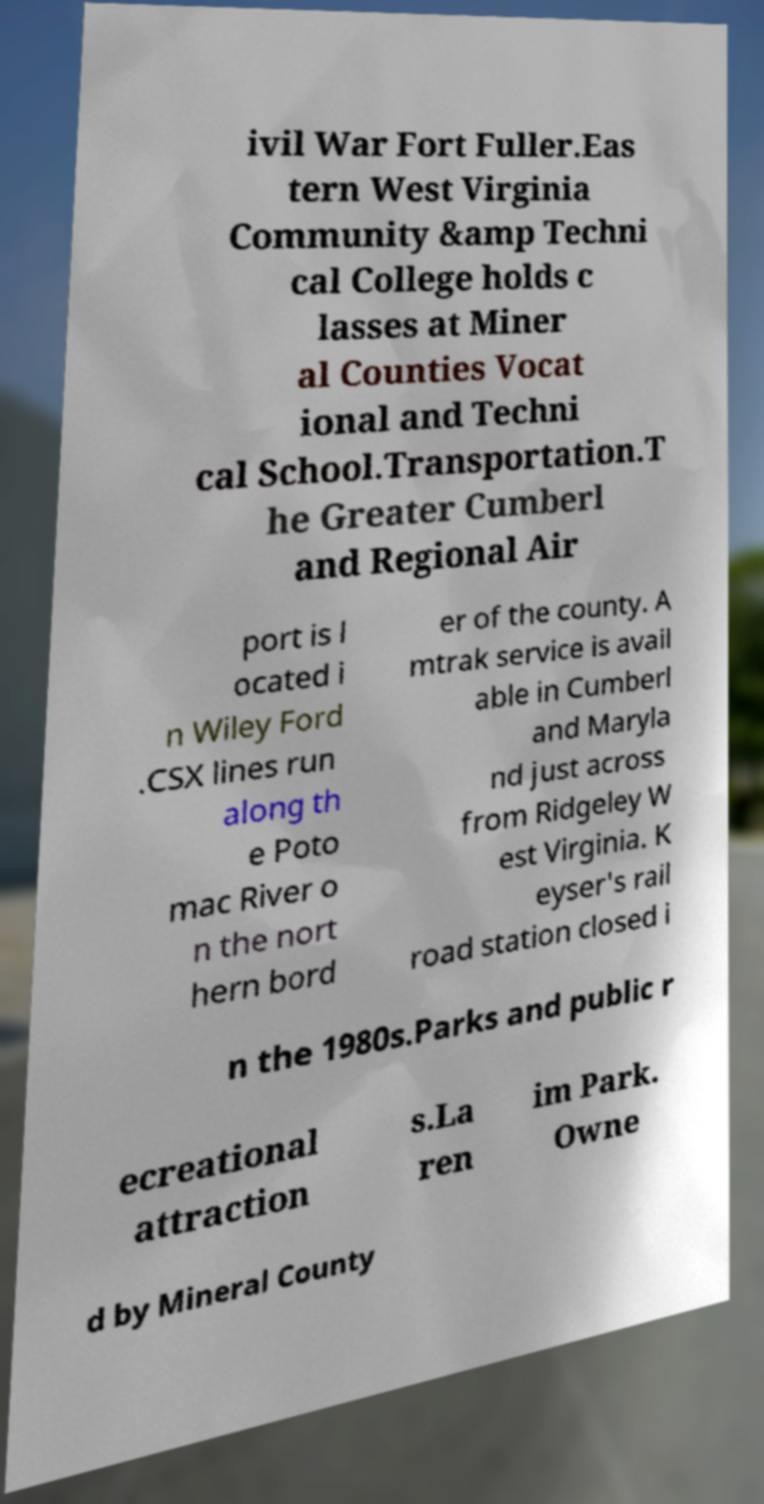Can you read and provide the text displayed in the image?This photo seems to have some interesting text. Can you extract and type it out for me? ivil War Fort Fuller.Eas tern West Virginia Community &amp Techni cal College holds c lasses at Miner al Counties Vocat ional and Techni cal School.Transportation.T he Greater Cumberl and Regional Air port is l ocated i n Wiley Ford .CSX lines run along th e Poto mac River o n the nort hern bord er of the county. A mtrak service is avail able in Cumberl and Maryla nd just across from Ridgeley W est Virginia. K eyser's rail road station closed i n the 1980s.Parks and public r ecreational attraction s.La ren im Park. Owne d by Mineral County 